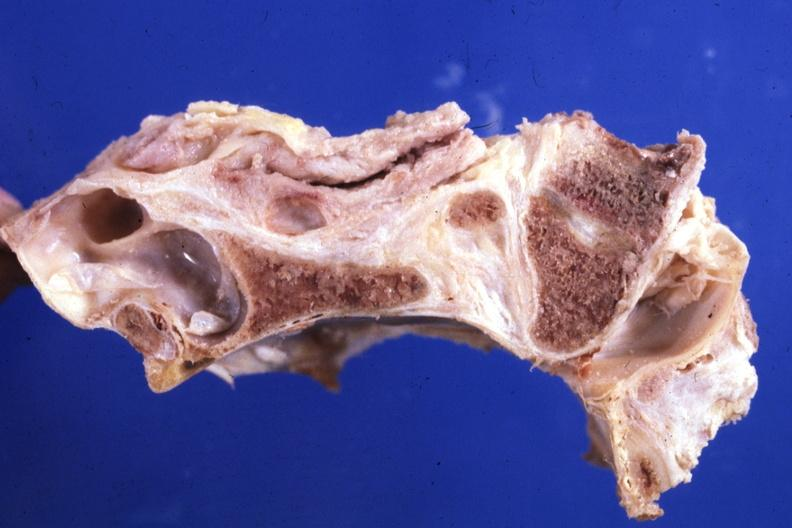what does this image show?
Answer the question using a single word or phrase. Sagittal section of atlas vertebra and occipital bone foramen magnum stenosis case 31 